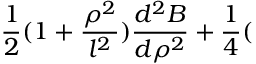<formula> <loc_0><loc_0><loc_500><loc_500>\frac { 1 } { 2 } ( 1 + \frac { \rho ^ { 2 } } { l ^ { 2 } } ) \frac { d ^ { 2 } B } { d \rho ^ { 2 } } + \frac { 1 } { 4 } (</formula> 